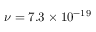<formula> <loc_0><loc_0><loc_500><loc_500>\nu = 7 . 3 \times 1 0 ^ { - 1 9 }</formula> 